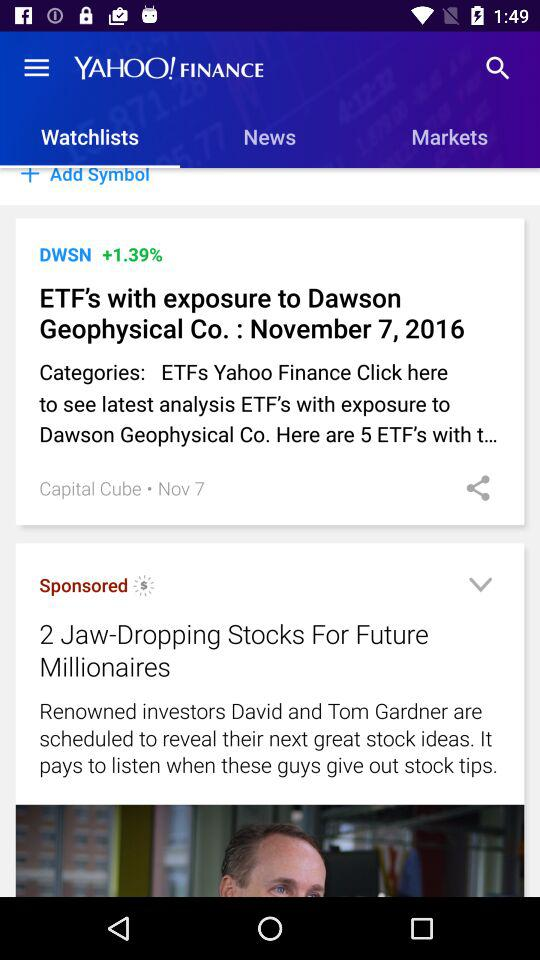What is the app name? The app name is "YAHOO! FINANCE". 